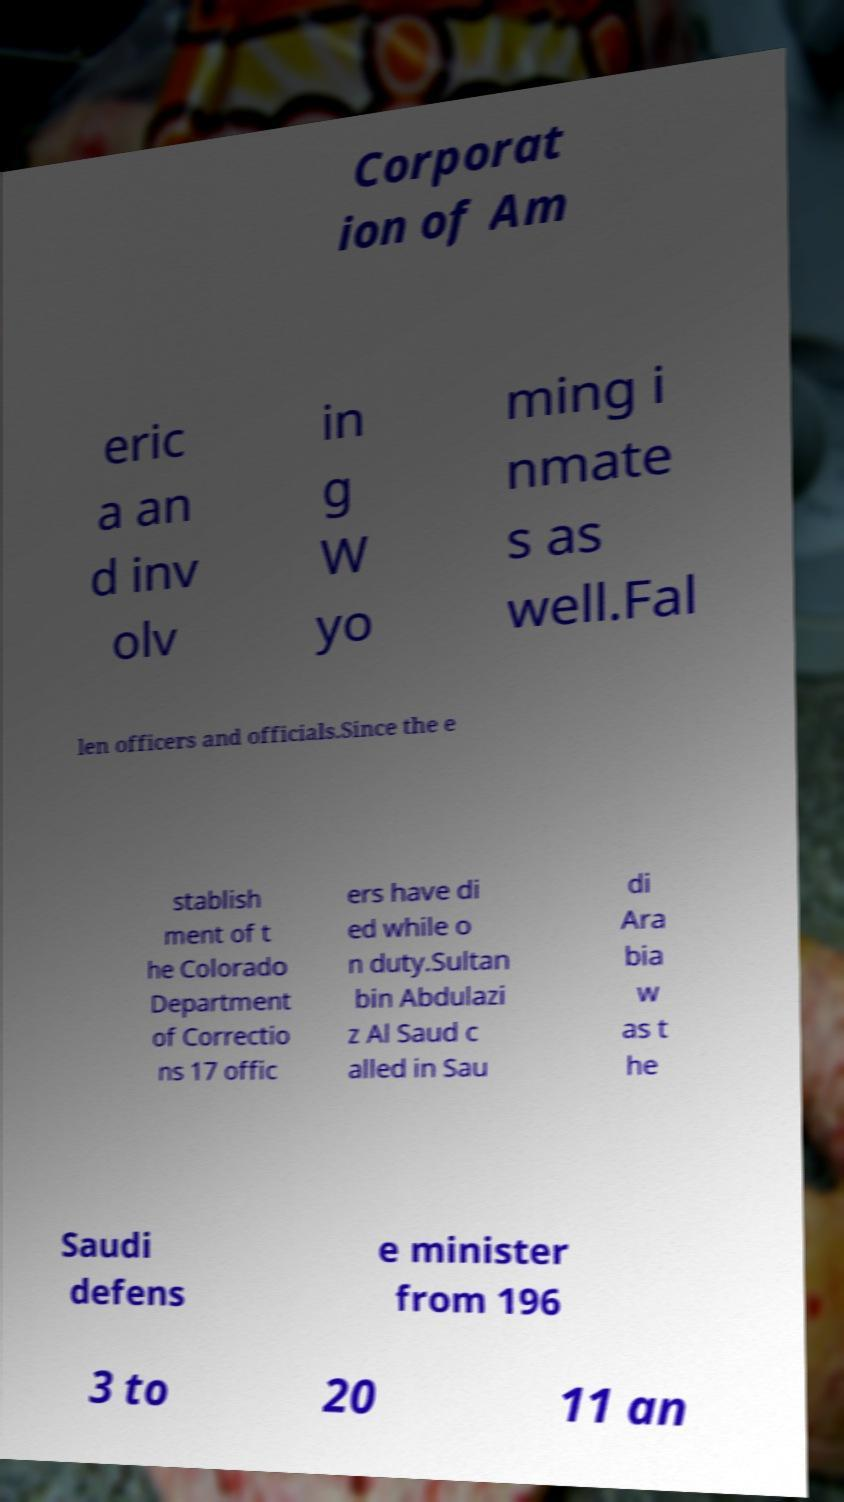Could you extract and type out the text from this image? Corporat ion of Am eric a an d inv olv in g W yo ming i nmate s as well.Fal len officers and officials.Since the e stablish ment of t he Colorado Department of Correctio ns 17 offic ers have di ed while o n duty.Sultan bin Abdulazi z Al Saud c alled in Sau di Ara bia w as t he Saudi defens e minister from 196 3 to 20 11 an 